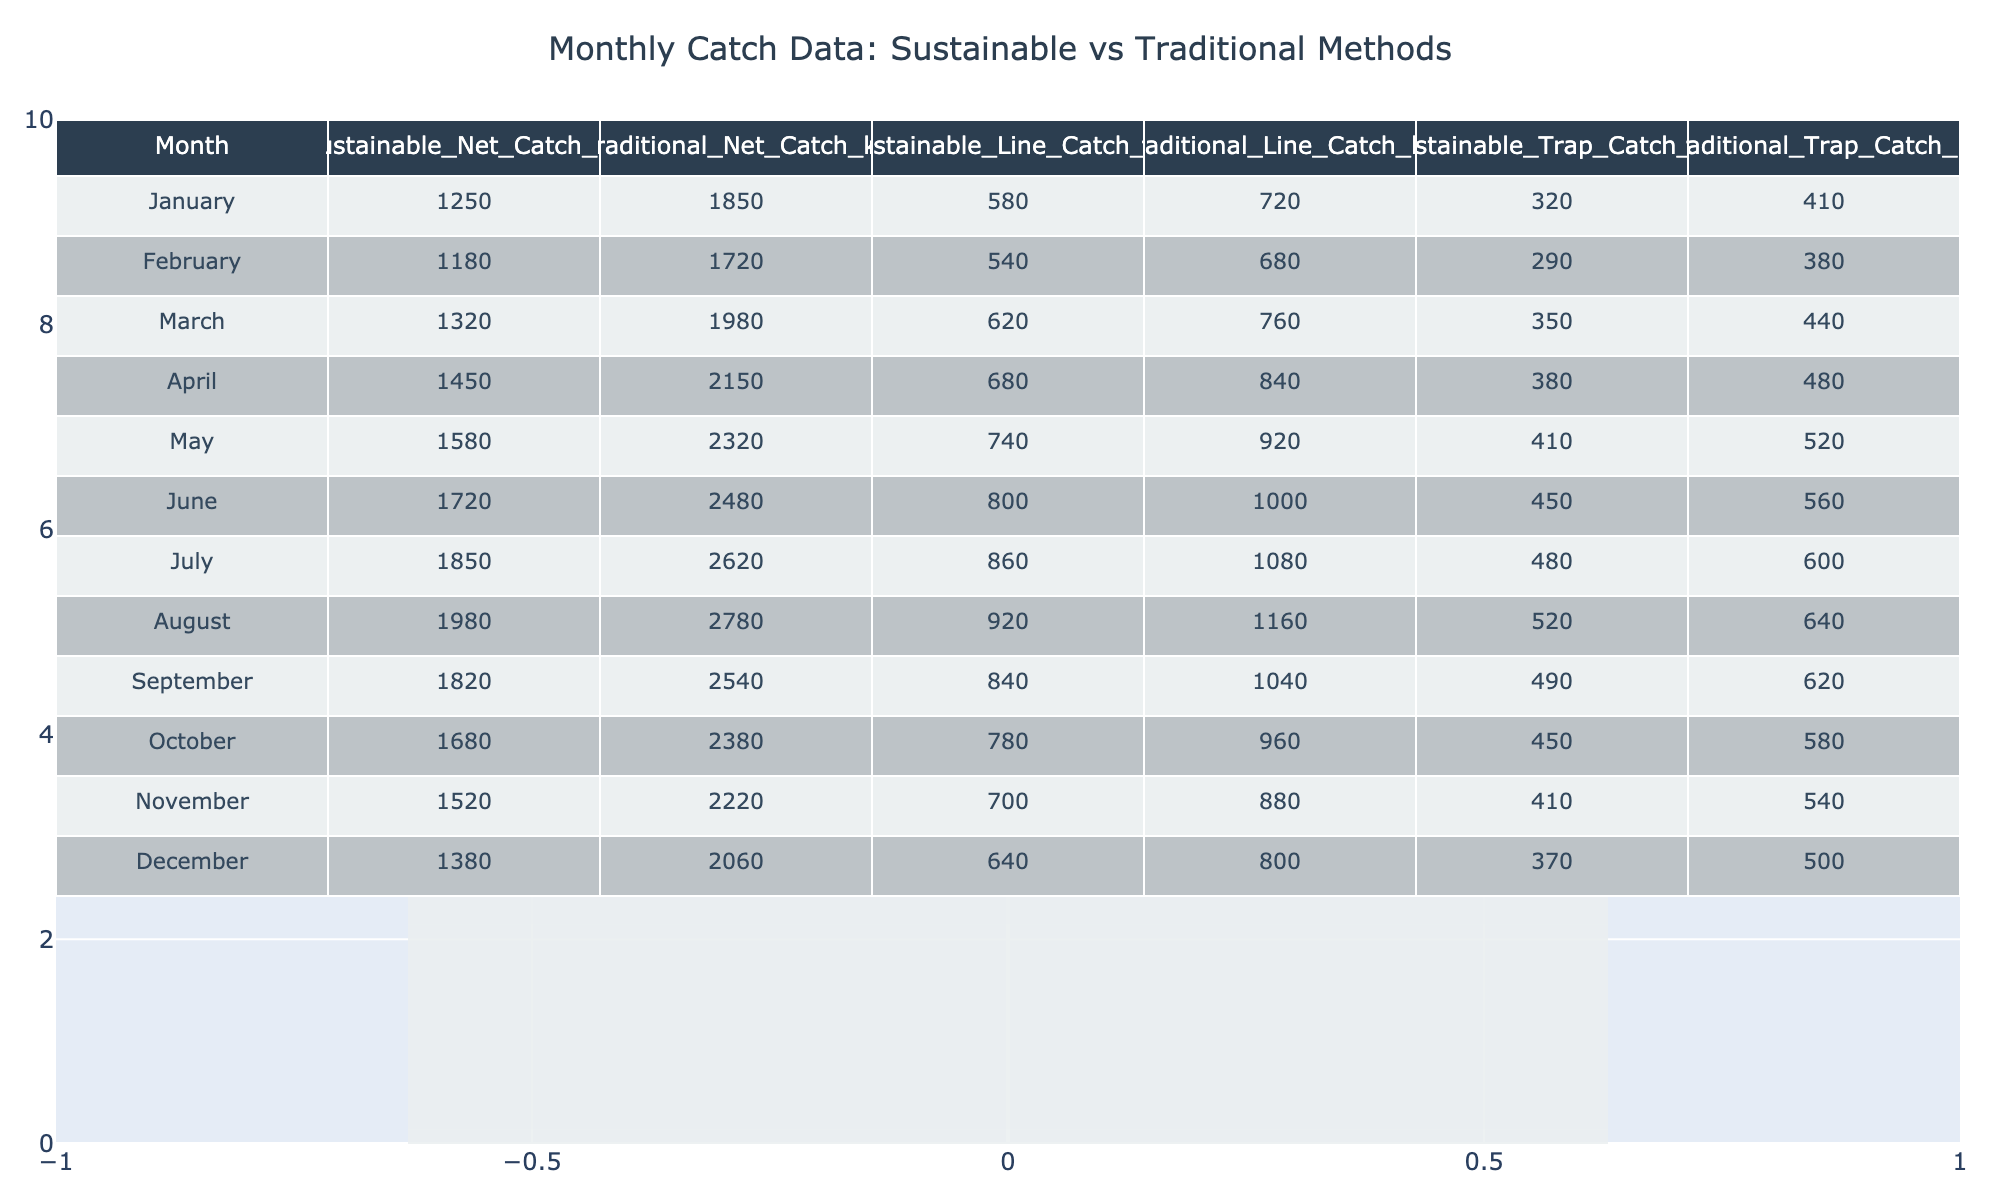What was the highest catch recorded for sustainable fishing methods in a single month? The table lists the sustainable net catch for each month. The highest value is found in July at 1850 kg.
Answer: 1850 kg What was the lowest traditional trap catch recorded? The traditional trap catch is noted for each month, and the lowest value of 410 kg is seen in January.
Answer: 410 kg What is the total sustainable line catch for the year? The sustainable line catch for each month is summed: 580 + 540 + 620 + 680 + 740 + 800 + 860 + 920 + 840 + 780 + 700 + 640 = 8,720 kg.
Answer: 8720 kg Did sustainable fishing methods consistently yield more catch than traditional methods throughout the year? By comparing the monthly catches, sustainable methods yielded more in January, February, March, April, May, June, July, August, and November, while traditional methods were higher in September, October, and December. Therefore, it's not consistent.
Answer: No What is the average traditional net catch across the year? To find the average, add all values of traditional net catches: 1850 + 1720 + 1980 + 2150 + 2320 + 2480 + 2620 + 2780 + 2540 + 2380 + 2220 + 2060 = 26,880 kg. There are 12 months, so the average is 26,880 / 12 = 2,240 kg.
Answer: 2240 kg Which method had the largest total catch over the year? Summing catches for each method: Sustainable Net = 18,880 kg, Sustainable Line = 8,720 kg, Sustainable Trap = 4,770 kg. Traditional Net = 26,880 kg, Traditional Line = 11,720 kg, Traditional Trap = 6,550 kg. Comparing totals reveals that traditional net catch is highest at 26,880 kg.
Answer: Traditional net catch In which month did sustainable methods have their lowest net catch? Looking at the sustainable net catch values, January shows the lowest at 1250 kg.
Answer: January What was the difference between the sustainable and traditional trap catches combined over the year? First, calculate total sustainable trap catch (4,770 kg) and traditional trap catch (6,550 kg). The difference is 6,550 - 4,770 = 1,780 kg.
Answer: 1780 kg Was there a month where the sustainable line catch exceeded 800 kg? Checking the monthly sustainable line catches, all values are above 800 kg from June to August: June (800 kg), July (860 kg), August (920 kg). Thus, there were months with higher catches.
Answer: Yes What percentage of the total catch for sustainable fishing methods is attributed to net catch? Total sustainable catch = 18,880 (net) + 8,720 (line) + 4,770 (trap) = 32,370 kg. The percentage for net catch is (18,880 / 32,370) * 100 = 58.3%.
Answer: 58.3% 